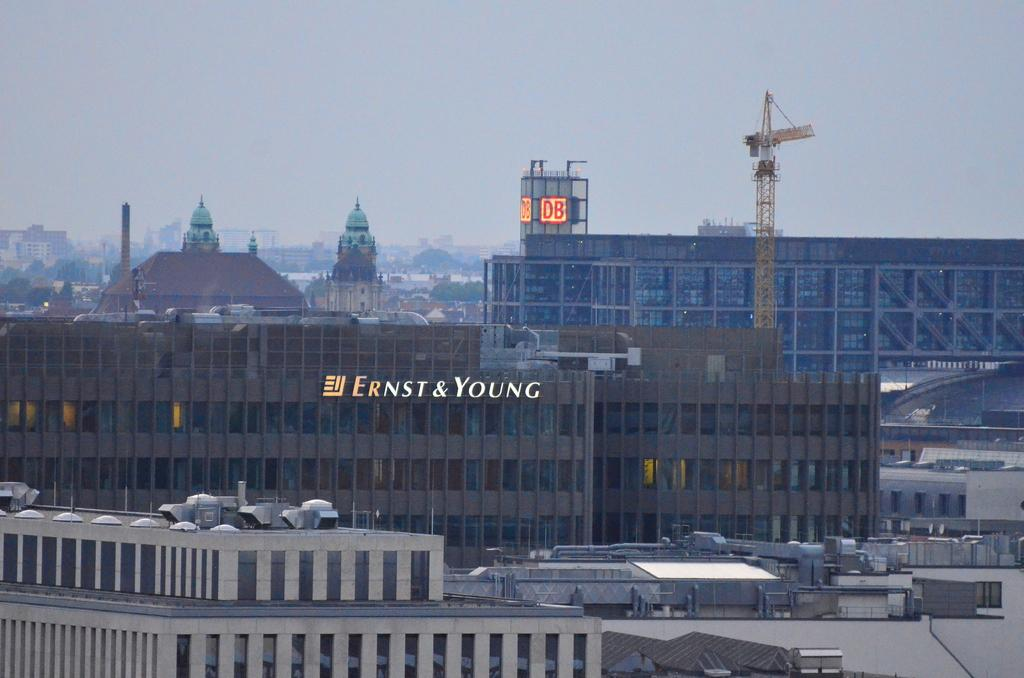What type of structures are visible in the image? There are big buildings in the image. What is the condition of the sky in the image? The sky is cloudy at the top of the image. What type of chair is depicted in the image? There is no chair present in the image. How many parcels can be seen in the image? There are no parcels present in the image. 